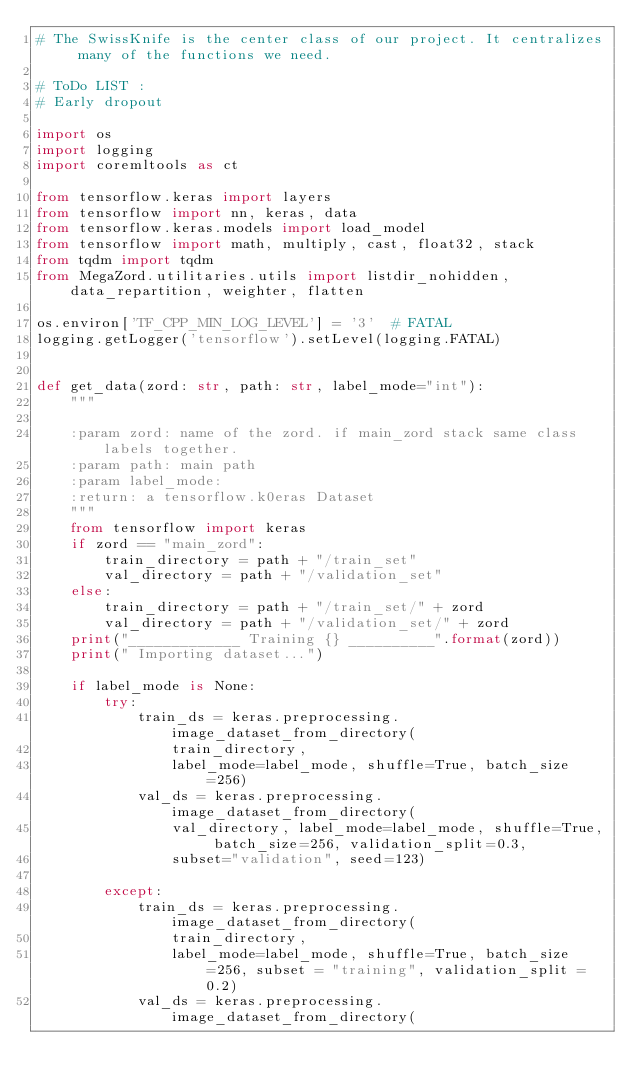<code> <loc_0><loc_0><loc_500><loc_500><_Python_># The SwissKnife is the center class of our project. It centralizes many of the functions we need.

# ToDo LIST :
# Early dropout

import os
import logging
import coremltools as ct

from tensorflow.keras import layers
from tensorflow import nn, keras, data
from tensorflow.keras.models import load_model
from tensorflow import math, multiply, cast, float32, stack
from tqdm import tqdm
from MegaZord.utilitaries.utils import listdir_nohidden, data_repartition, weighter, flatten

os.environ['TF_CPP_MIN_LOG_LEVEL'] = '3'  # FATAL
logging.getLogger('tensorflow').setLevel(logging.FATAL)


def get_data(zord: str, path: str, label_mode="int"):
    """

    :param zord: name of the zord. if main_zord stack same class labels together.
    :param path: main path
    :param label_mode:
    :return: a tensorflow.k0eras Dataset
    """
    from tensorflow import keras
    if zord == "main_zord":
        train_directory = path + "/train_set"
        val_directory = path + "/validation_set"
    else:
        train_directory = path + "/train_set/" + zord
        val_directory = path + "/validation_set/" + zord
    print("_____________ Training {} __________".format(zord))
    print(" Importing dataset...")

    if label_mode is None:
        try:
            train_ds = keras.preprocessing.image_dataset_from_directory(
                train_directory,
                label_mode=label_mode, shuffle=True, batch_size=256)
            val_ds = keras.preprocessing.image_dataset_from_directory(
                val_directory, label_mode=label_mode, shuffle=True, batch_size=256, validation_split=0.3,
                subset="validation", seed=123)

        except:
            train_ds = keras.preprocessing.image_dataset_from_directory(
                train_directory,
                label_mode=label_mode, shuffle=True, batch_size=256, subset = "training", validation_split = 0.2)
            val_ds = keras.preprocessing.image_dataset_from_directory(</code> 